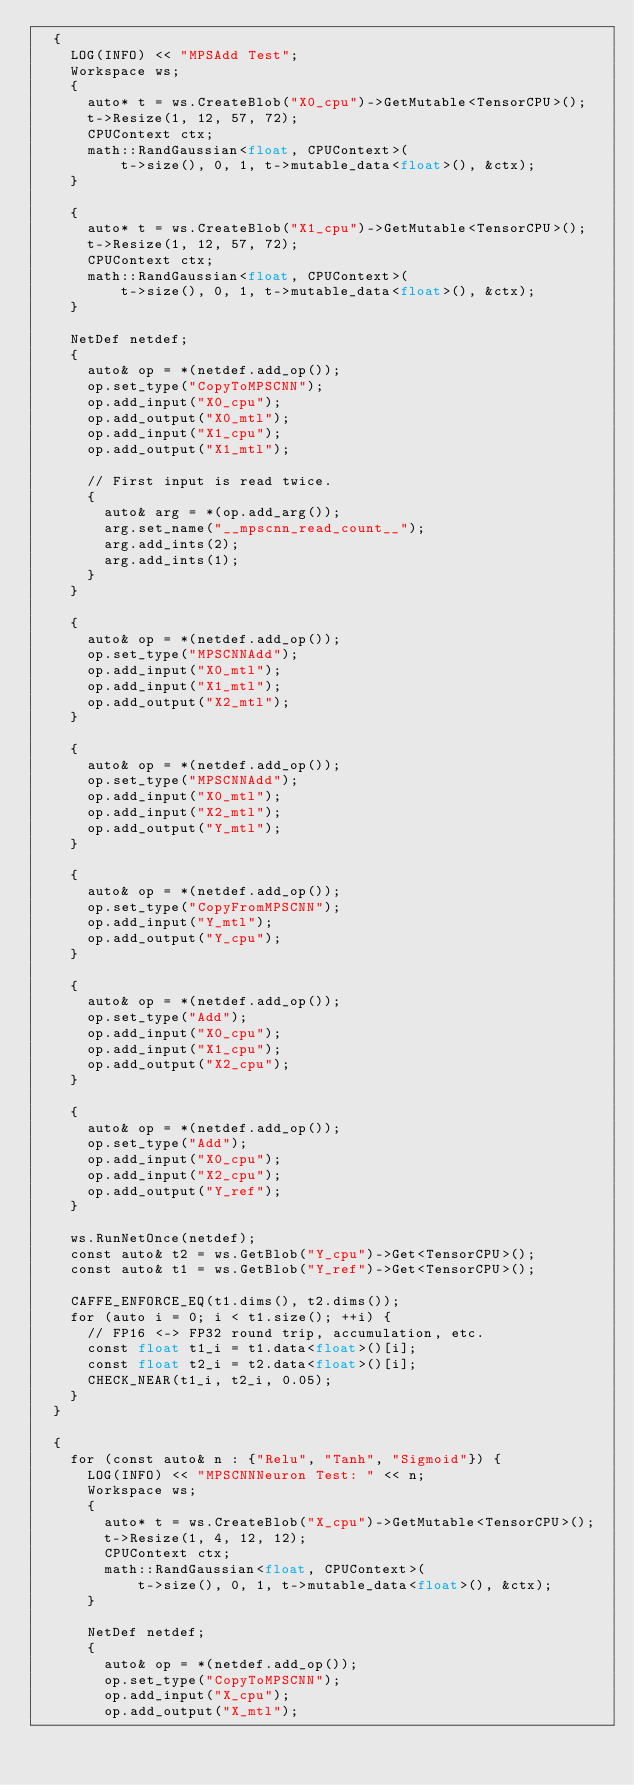<code> <loc_0><loc_0><loc_500><loc_500><_ObjectiveC_>  {
    LOG(INFO) << "MPSAdd Test";
    Workspace ws;
    {
      auto* t = ws.CreateBlob("X0_cpu")->GetMutable<TensorCPU>();
      t->Resize(1, 12, 57, 72);
      CPUContext ctx;
      math::RandGaussian<float, CPUContext>(
          t->size(), 0, 1, t->mutable_data<float>(), &ctx);
    }

    {
      auto* t = ws.CreateBlob("X1_cpu")->GetMutable<TensorCPU>();
      t->Resize(1, 12, 57, 72);
      CPUContext ctx;
      math::RandGaussian<float, CPUContext>(
          t->size(), 0, 1, t->mutable_data<float>(), &ctx);
    }

    NetDef netdef;
    {
      auto& op = *(netdef.add_op());
      op.set_type("CopyToMPSCNN");
      op.add_input("X0_cpu");
      op.add_output("X0_mtl");
      op.add_input("X1_cpu");
      op.add_output("X1_mtl");

      // First input is read twice.
      {
        auto& arg = *(op.add_arg());
        arg.set_name("__mpscnn_read_count__");
        arg.add_ints(2);
        arg.add_ints(1);
      }
    }

    {
      auto& op = *(netdef.add_op());
      op.set_type("MPSCNNAdd");
      op.add_input("X0_mtl");
      op.add_input("X1_mtl");
      op.add_output("X2_mtl");
    }

    {
      auto& op = *(netdef.add_op());
      op.set_type("MPSCNNAdd");
      op.add_input("X0_mtl");
      op.add_input("X2_mtl");
      op.add_output("Y_mtl");
    }

    {
      auto& op = *(netdef.add_op());
      op.set_type("CopyFromMPSCNN");
      op.add_input("Y_mtl");
      op.add_output("Y_cpu");
    }

    {
      auto& op = *(netdef.add_op());
      op.set_type("Add");
      op.add_input("X0_cpu");
      op.add_input("X1_cpu");
      op.add_output("X2_cpu");
    }

    {
      auto& op = *(netdef.add_op());
      op.set_type("Add");
      op.add_input("X0_cpu");
      op.add_input("X2_cpu");
      op.add_output("Y_ref");
    }

    ws.RunNetOnce(netdef);
    const auto& t2 = ws.GetBlob("Y_cpu")->Get<TensorCPU>();
    const auto& t1 = ws.GetBlob("Y_ref")->Get<TensorCPU>();

    CAFFE_ENFORCE_EQ(t1.dims(), t2.dims());
    for (auto i = 0; i < t1.size(); ++i) {
      // FP16 <-> FP32 round trip, accumulation, etc.
      const float t1_i = t1.data<float>()[i];
      const float t2_i = t2.data<float>()[i];
      CHECK_NEAR(t1_i, t2_i, 0.05);
    }
  }

  {
    for (const auto& n : {"Relu", "Tanh", "Sigmoid"}) {
      LOG(INFO) << "MPSCNNNeuron Test: " << n;
      Workspace ws;
      {
        auto* t = ws.CreateBlob("X_cpu")->GetMutable<TensorCPU>();
        t->Resize(1, 4, 12, 12);
        CPUContext ctx;
        math::RandGaussian<float, CPUContext>(
            t->size(), 0, 1, t->mutable_data<float>(), &ctx);
      }

      NetDef netdef;
      {
        auto& op = *(netdef.add_op());
        op.set_type("CopyToMPSCNN");
        op.add_input("X_cpu");
        op.add_output("X_mtl");</code> 